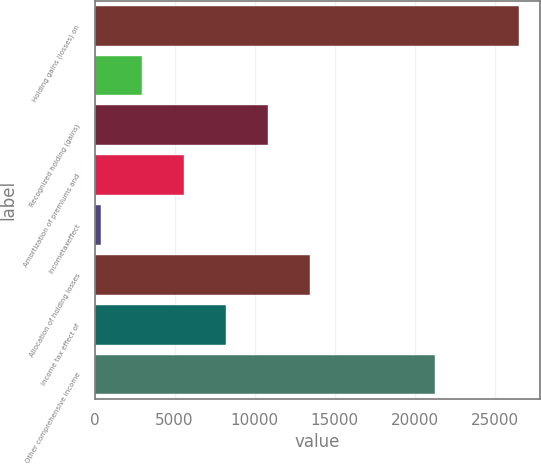Convert chart. <chart><loc_0><loc_0><loc_500><loc_500><bar_chart><fcel>Holding gains (losses) on<fcel>Unnamed: 1<fcel>Recognized holding (gains)<fcel>Amortization of premiums and<fcel>Incometaxeffect<fcel>Allocation of holding losses<fcel>Income tax effect of<fcel>Other comprehensive income<nl><fcel>26491<fcel>2988.4<fcel>10822.6<fcel>5599.8<fcel>377<fcel>13434<fcel>8211.2<fcel>21268.2<nl></chart> 